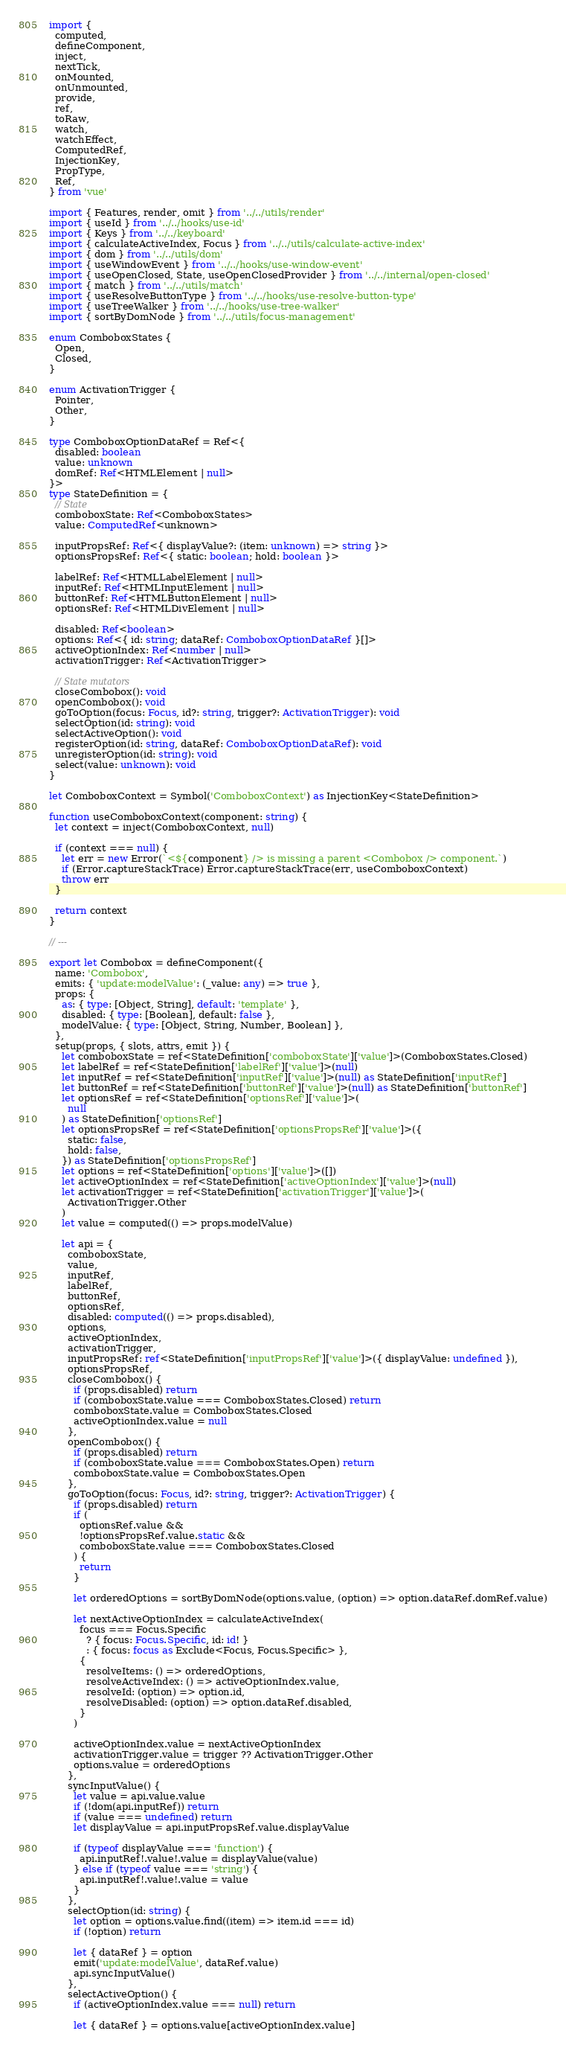Convert code to text. <code><loc_0><loc_0><loc_500><loc_500><_TypeScript_>import {
  computed,
  defineComponent,
  inject,
  nextTick,
  onMounted,
  onUnmounted,
  provide,
  ref,
  toRaw,
  watch,
  watchEffect,
  ComputedRef,
  InjectionKey,
  PropType,
  Ref,
} from 'vue'

import { Features, render, omit } from '../../utils/render'
import { useId } from '../../hooks/use-id'
import { Keys } from '../../keyboard'
import { calculateActiveIndex, Focus } from '../../utils/calculate-active-index'
import { dom } from '../../utils/dom'
import { useWindowEvent } from '../../hooks/use-window-event'
import { useOpenClosed, State, useOpenClosedProvider } from '../../internal/open-closed'
import { match } from '../../utils/match'
import { useResolveButtonType } from '../../hooks/use-resolve-button-type'
import { useTreeWalker } from '../../hooks/use-tree-walker'
import { sortByDomNode } from '../../utils/focus-management'

enum ComboboxStates {
  Open,
  Closed,
}

enum ActivationTrigger {
  Pointer,
  Other,
}

type ComboboxOptionDataRef = Ref<{
  disabled: boolean
  value: unknown
  domRef: Ref<HTMLElement | null>
}>
type StateDefinition = {
  // State
  comboboxState: Ref<ComboboxStates>
  value: ComputedRef<unknown>

  inputPropsRef: Ref<{ displayValue?: (item: unknown) => string }>
  optionsPropsRef: Ref<{ static: boolean; hold: boolean }>

  labelRef: Ref<HTMLLabelElement | null>
  inputRef: Ref<HTMLInputElement | null>
  buttonRef: Ref<HTMLButtonElement | null>
  optionsRef: Ref<HTMLDivElement | null>

  disabled: Ref<boolean>
  options: Ref<{ id: string; dataRef: ComboboxOptionDataRef }[]>
  activeOptionIndex: Ref<number | null>
  activationTrigger: Ref<ActivationTrigger>

  // State mutators
  closeCombobox(): void
  openCombobox(): void
  goToOption(focus: Focus, id?: string, trigger?: ActivationTrigger): void
  selectOption(id: string): void
  selectActiveOption(): void
  registerOption(id: string, dataRef: ComboboxOptionDataRef): void
  unregisterOption(id: string): void
  select(value: unknown): void
}

let ComboboxContext = Symbol('ComboboxContext') as InjectionKey<StateDefinition>

function useComboboxContext(component: string) {
  let context = inject(ComboboxContext, null)

  if (context === null) {
    let err = new Error(`<${component} /> is missing a parent <Combobox /> component.`)
    if (Error.captureStackTrace) Error.captureStackTrace(err, useComboboxContext)
    throw err
  }

  return context
}

// ---

export let Combobox = defineComponent({
  name: 'Combobox',
  emits: { 'update:modelValue': (_value: any) => true },
  props: {
    as: { type: [Object, String], default: 'template' },
    disabled: { type: [Boolean], default: false },
    modelValue: { type: [Object, String, Number, Boolean] },
  },
  setup(props, { slots, attrs, emit }) {
    let comboboxState = ref<StateDefinition['comboboxState']['value']>(ComboboxStates.Closed)
    let labelRef = ref<StateDefinition['labelRef']['value']>(null)
    let inputRef = ref<StateDefinition['inputRef']['value']>(null) as StateDefinition['inputRef']
    let buttonRef = ref<StateDefinition['buttonRef']['value']>(null) as StateDefinition['buttonRef']
    let optionsRef = ref<StateDefinition['optionsRef']['value']>(
      null
    ) as StateDefinition['optionsRef']
    let optionsPropsRef = ref<StateDefinition['optionsPropsRef']['value']>({
      static: false,
      hold: false,
    }) as StateDefinition['optionsPropsRef']
    let options = ref<StateDefinition['options']['value']>([])
    let activeOptionIndex = ref<StateDefinition['activeOptionIndex']['value']>(null)
    let activationTrigger = ref<StateDefinition['activationTrigger']['value']>(
      ActivationTrigger.Other
    )
    let value = computed(() => props.modelValue)

    let api = {
      comboboxState,
      value,
      inputRef,
      labelRef,
      buttonRef,
      optionsRef,
      disabled: computed(() => props.disabled),
      options,
      activeOptionIndex,
      activationTrigger,
      inputPropsRef: ref<StateDefinition['inputPropsRef']['value']>({ displayValue: undefined }),
      optionsPropsRef,
      closeCombobox() {
        if (props.disabled) return
        if (comboboxState.value === ComboboxStates.Closed) return
        comboboxState.value = ComboboxStates.Closed
        activeOptionIndex.value = null
      },
      openCombobox() {
        if (props.disabled) return
        if (comboboxState.value === ComboboxStates.Open) return
        comboboxState.value = ComboboxStates.Open
      },
      goToOption(focus: Focus, id?: string, trigger?: ActivationTrigger) {
        if (props.disabled) return
        if (
          optionsRef.value &&
          !optionsPropsRef.value.static &&
          comboboxState.value === ComboboxStates.Closed
        ) {
          return
        }

        let orderedOptions = sortByDomNode(options.value, (option) => option.dataRef.domRef.value)

        let nextActiveOptionIndex = calculateActiveIndex(
          focus === Focus.Specific
            ? { focus: Focus.Specific, id: id! }
            : { focus: focus as Exclude<Focus, Focus.Specific> },
          {
            resolveItems: () => orderedOptions,
            resolveActiveIndex: () => activeOptionIndex.value,
            resolveId: (option) => option.id,
            resolveDisabled: (option) => option.dataRef.disabled,
          }
        )

        activeOptionIndex.value = nextActiveOptionIndex
        activationTrigger.value = trigger ?? ActivationTrigger.Other
        options.value = orderedOptions
      },
      syncInputValue() {
        let value = api.value.value
        if (!dom(api.inputRef)) return
        if (value === undefined) return
        let displayValue = api.inputPropsRef.value.displayValue

        if (typeof displayValue === 'function') {
          api.inputRef!.value!.value = displayValue(value)
        } else if (typeof value === 'string') {
          api.inputRef!.value!.value = value
        }
      },
      selectOption(id: string) {
        let option = options.value.find((item) => item.id === id)
        if (!option) return

        let { dataRef } = option
        emit('update:modelValue', dataRef.value)
        api.syncInputValue()
      },
      selectActiveOption() {
        if (activeOptionIndex.value === null) return

        let { dataRef } = options.value[activeOptionIndex.value]</code> 